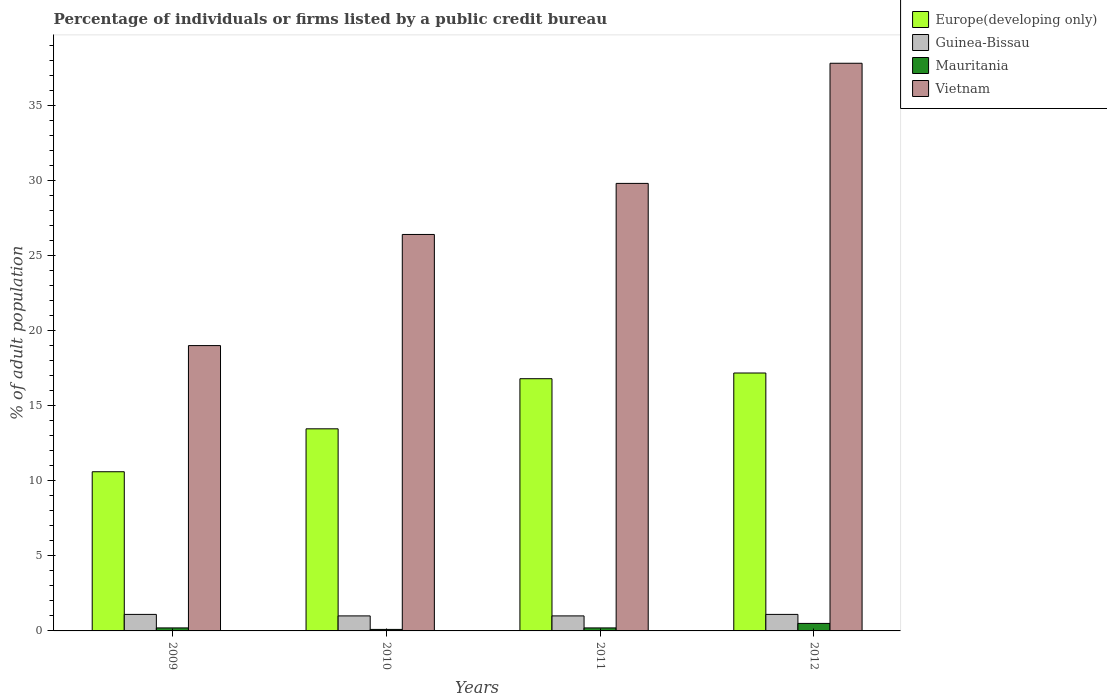How many different coloured bars are there?
Keep it short and to the point. 4. Are the number of bars per tick equal to the number of legend labels?
Provide a short and direct response. Yes. Are the number of bars on each tick of the X-axis equal?
Your answer should be very brief. Yes. How many bars are there on the 2nd tick from the left?
Your answer should be compact. 4. What is the label of the 4th group of bars from the left?
Make the answer very short. 2012. What is the percentage of population listed by a public credit bureau in Europe(developing only) in 2009?
Ensure brevity in your answer.  10.6. Across all years, what is the maximum percentage of population listed by a public credit bureau in Guinea-Bissau?
Your response must be concise. 1.1. Across all years, what is the minimum percentage of population listed by a public credit bureau in Europe(developing only)?
Provide a short and direct response. 10.6. What is the total percentage of population listed by a public credit bureau in Vietnam in the graph?
Offer a terse response. 113. What is the difference between the percentage of population listed by a public credit bureau in Mauritania in 2009 and that in 2010?
Make the answer very short. 0.1. What is the difference between the percentage of population listed by a public credit bureau in Mauritania in 2009 and the percentage of population listed by a public credit bureau in Europe(developing only) in 2012?
Your answer should be very brief. -16.97. In the year 2010, what is the difference between the percentage of population listed by a public credit bureau in Mauritania and percentage of population listed by a public credit bureau in Vietnam?
Make the answer very short. -26.3. What is the ratio of the percentage of population listed by a public credit bureau in Europe(developing only) in 2010 to that in 2012?
Provide a short and direct response. 0.78. What is the difference between the highest and the second highest percentage of population listed by a public credit bureau in Vietnam?
Provide a short and direct response. 8. What is the difference between the highest and the lowest percentage of population listed by a public credit bureau in Mauritania?
Provide a succinct answer. 0.4. What does the 1st bar from the left in 2012 represents?
Keep it short and to the point. Europe(developing only). What does the 2nd bar from the right in 2011 represents?
Provide a short and direct response. Mauritania. Are all the bars in the graph horizontal?
Keep it short and to the point. No. Are the values on the major ticks of Y-axis written in scientific E-notation?
Offer a very short reply. No. How many legend labels are there?
Make the answer very short. 4. What is the title of the graph?
Offer a terse response. Percentage of individuals or firms listed by a public credit bureau. What is the label or title of the Y-axis?
Make the answer very short. % of adult population. What is the % of adult population of Guinea-Bissau in 2009?
Your answer should be compact. 1.1. What is the % of adult population in Mauritania in 2009?
Provide a succinct answer. 0.2. What is the % of adult population of Vietnam in 2009?
Provide a short and direct response. 19. What is the % of adult population in Europe(developing only) in 2010?
Provide a succinct answer. 13.46. What is the % of adult population in Guinea-Bissau in 2010?
Keep it short and to the point. 1. What is the % of adult population in Mauritania in 2010?
Give a very brief answer. 0.1. What is the % of adult population in Vietnam in 2010?
Provide a succinct answer. 26.4. What is the % of adult population in Europe(developing only) in 2011?
Offer a terse response. 16.79. What is the % of adult population of Vietnam in 2011?
Your response must be concise. 29.8. What is the % of adult population of Europe(developing only) in 2012?
Provide a succinct answer. 17.17. What is the % of adult population in Vietnam in 2012?
Make the answer very short. 37.8. Across all years, what is the maximum % of adult population in Europe(developing only)?
Make the answer very short. 17.17. Across all years, what is the maximum % of adult population in Guinea-Bissau?
Provide a succinct answer. 1.1. Across all years, what is the maximum % of adult population of Mauritania?
Provide a succinct answer. 0.5. Across all years, what is the maximum % of adult population of Vietnam?
Provide a short and direct response. 37.8. Across all years, what is the minimum % of adult population of Europe(developing only)?
Give a very brief answer. 10.6. What is the total % of adult population in Europe(developing only) in the graph?
Provide a succinct answer. 58.03. What is the total % of adult population of Vietnam in the graph?
Keep it short and to the point. 113. What is the difference between the % of adult population in Europe(developing only) in 2009 and that in 2010?
Your answer should be compact. -2.86. What is the difference between the % of adult population of Vietnam in 2009 and that in 2010?
Your answer should be compact. -7.4. What is the difference between the % of adult population in Europe(developing only) in 2009 and that in 2011?
Give a very brief answer. -6.19. What is the difference between the % of adult population in Guinea-Bissau in 2009 and that in 2011?
Offer a very short reply. 0.1. What is the difference between the % of adult population in Mauritania in 2009 and that in 2011?
Offer a terse response. 0. What is the difference between the % of adult population of Europe(developing only) in 2009 and that in 2012?
Offer a terse response. -6.57. What is the difference between the % of adult population in Vietnam in 2009 and that in 2012?
Make the answer very short. -18.8. What is the difference between the % of adult population in Europe(developing only) in 2010 and that in 2011?
Make the answer very short. -3.34. What is the difference between the % of adult population in Mauritania in 2010 and that in 2011?
Provide a short and direct response. -0.1. What is the difference between the % of adult population of Europe(developing only) in 2010 and that in 2012?
Provide a short and direct response. -3.72. What is the difference between the % of adult population in Mauritania in 2010 and that in 2012?
Provide a succinct answer. -0.4. What is the difference between the % of adult population in Europe(developing only) in 2011 and that in 2012?
Ensure brevity in your answer.  -0.38. What is the difference between the % of adult population in Guinea-Bissau in 2011 and that in 2012?
Offer a terse response. -0.1. What is the difference between the % of adult population in Europe(developing only) in 2009 and the % of adult population in Mauritania in 2010?
Provide a succinct answer. 10.5. What is the difference between the % of adult population of Europe(developing only) in 2009 and the % of adult population of Vietnam in 2010?
Your answer should be very brief. -15.8. What is the difference between the % of adult population of Guinea-Bissau in 2009 and the % of adult population of Vietnam in 2010?
Your answer should be very brief. -25.3. What is the difference between the % of adult population in Mauritania in 2009 and the % of adult population in Vietnam in 2010?
Keep it short and to the point. -26.2. What is the difference between the % of adult population of Europe(developing only) in 2009 and the % of adult population of Mauritania in 2011?
Your response must be concise. 10.4. What is the difference between the % of adult population in Europe(developing only) in 2009 and the % of adult population in Vietnam in 2011?
Ensure brevity in your answer.  -19.2. What is the difference between the % of adult population in Guinea-Bissau in 2009 and the % of adult population in Mauritania in 2011?
Keep it short and to the point. 0.9. What is the difference between the % of adult population of Guinea-Bissau in 2009 and the % of adult population of Vietnam in 2011?
Your answer should be very brief. -28.7. What is the difference between the % of adult population of Mauritania in 2009 and the % of adult population of Vietnam in 2011?
Make the answer very short. -29.6. What is the difference between the % of adult population of Europe(developing only) in 2009 and the % of adult population of Guinea-Bissau in 2012?
Offer a terse response. 9.5. What is the difference between the % of adult population in Europe(developing only) in 2009 and the % of adult population in Mauritania in 2012?
Offer a very short reply. 10.1. What is the difference between the % of adult population of Europe(developing only) in 2009 and the % of adult population of Vietnam in 2012?
Offer a terse response. -27.2. What is the difference between the % of adult population in Guinea-Bissau in 2009 and the % of adult population in Vietnam in 2012?
Make the answer very short. -36.7. What is the difference between the % of adult population of Mauritania in 2009 and the % of adult population of Vietnam in 2012?
Provide a succinct answer. -37.6. What is the difference between the % of adult population in Europe(developing only) in 2010 and the % of adult population in Guinea-Bissau in 2011?
Offer a terse response. 12.46. What is the difference between the % of adult population of Europe(developing only) in 2010 and the % of adult population of Mauritania in 2011?
Ensure brevity in your answer.  13.26. What is the difference between the % of adult population in Europe(developing only) in 2010 and the % of adult population in Vietnam in 2011?
Make the answer very short. -16.34. What is the difference between the % of adult population in Guinea-Bissau in 2010 and the % of adult population in Mauritania in 2011?
Provide a succinct answer. 0.8. What is the difference between the % of adult population of Guinea-Bissau in 2010 and the % of adult population of Vietnam in 2011?
Your response must be concise. -28.8. What is the difference between the % of adult population of Mauritania in 2010 and the % of adult population of Vietnam in 2011?
Keep it short and to the point. -29.7. What is the difference between the % of adult population in Europe(developing only) in 2010 and the % of adult population in Guinea-Bissau in 2012?
Make the answer very short. 12.36. What is the difference between the % of adult population of Europe(developing only) in 2010 and the % of adult population of Mauritania in 2012?
Your response must be concise. 12.96. What is the difference between the % of adult population of Europe(developing only) in 2010 and the % of adult population of Vietnam in 2012?
Offer a very short reply. -24.34. What is the difference between the % of adult population of Guinea-Bissau in 2010 and the % of adult population of Vietnam in 2012?
Your answer should be very brief. -36.8. What is the difference between the % of adult population in Mauritania in 2010 and the % of adult population in Vietnam in 2012?
Give a very brief answer. -37.7. What is the difference between the % of adult population in Europe(developing only) in 2011 and the % of adult population in Guinea-Bissau in 2012?
Your response must be concise. 15.69. What is the difference between the % of adult population in Europe(developing only) in 2011 and the % of adult population in Mauritania in 2012?
Ensure brevity in your answer.  16.29. What is the difference between the % of adult population of Europe(developing only) in 2011 and the % of adult population of Vietnam in 2012?
Offer a terse response. -21.01. What is the difference between the % of adult population of Guinea-Bissau in 2011 and the % of adult population of Mauritania in 2012?
Offer a terse response. 0.5. What is the difference between the % of adult population of Guinea-Bissau in 2011 and the % of adult population of Vietnam in 2012?
Offer a very short reply. -36.8. What is the difference between the % of adult population of Mauritania in 2011 and the % of adult population of Vietnam in 2012?
Your answer should be compact. -37.6. What is the average % of adult population of Europe(developing only) per year?
Your response must be concise. 14.51. What is the average % of adult population of Vietnam per year?
Ensure brevity in your answer.  28.25. In the year 2009, what is the difference between the % of adult population in Europe(developing only) and % of adult population in Guinea-Bissau?
Your response must be concise. 9.5. In the year 2009, what is the difference between the % of adult population in Europe(developing only) and % of adult population in Mauritania?
Offer a very short reply. 10.4. In the year 2009, what is the difference between the % of adult population in Guinea-Bissau and % of adult population in Mauritania?
Keep it short and to the point. 0.9. In the year 2009, what is the difference between the % of adult population of Guinea-Bissau and % of adult population of Vietnam?
Provide a short and direct response. -17.9. In the year 2009, what is the difference between the % of adult population in Mauritania and % of adult population in Vietnam?
Ensure brevity in your answer.  -18.8. In the year 2010, what is the difference between the % of adult population of Europe(developing only) and % of adult population of Guinea-Bissau?
Make the answer very short. 12.46. In the year 2010, what is the difference between the % of adult population in Europe(developing only) and % of adult population in Mauritania?
Offer a very short reply. 13.36. In the year 2010, what is the difference between the % of adult population of Europe(developing only) and % of adult population of Vietnam?
Keep it short and to the point. -12.94. In the year 2010, what is the difference between the % of adult population in Guinea-Bissau and % of adult population in Mauritania?
Offer a very short reply. 0.9. In the year 2010, what is the difference between the % of adult population of Guinea-Bissau and % of adult population of Vietnam?
Provide a short and direct response. -25.4. In the year 2010, what is the difference between the % of adult population of Mauritania and % of adult population of Vietnam?
Offer a very short reply. -26.3. In the year 2011, what is the difference between the % of adult population of Europe(developing only) and % of adult population of Guinea-Bissau?
Keep it short and to the point. 15.79. In the year 2011, what is the difference between the % of adult population of Europe(developing only) and % of adult population of Mauritania?
Your answer should be compact. 16.59. In the year 2011, what is the difference between the % of adult population of Europe(developing only) and % of adult population of Vietnam?
Keep it short and to the point. -13.01. In the year 2011, what is the difference between the % of adult population in Guinea-Bissau and % of adult population in Mauritania?
Your response must be concise. 0.8. In the year 2011, what is the difference between the % of adult population of Guinea-Bissau and % of adult population of Vietnam?
Your response must be concise. -28.8. In the year 2011, what is the difference between the % of adult population in Mauritania and % of adult population in Vietnam?
Give a very brief answer. -29.6. In the year 2012, what is the difference between the % of adult population in Europe(developing only) and % of adult population in Guinea-Bissau?
Keep it short and to the point. 16.07. In the year 2012, what is the difference between the % of adult population in Europe(developing only) and % of adult population in Mauritania?
Give a very brief answer. 16.67. In the year 2012, what is the difference between the % of adult population in Europe(developing only) and % of adult population in Vietnam?
Your answer should be compact. -20.63. In the year 2012, what is the difference between the % of adult population of Guinea-Bissau and % of adult population of Mauritania?
Your answer should be very brief. 0.6. In the year 2012, what is the difference between the % of adult population of Guinea-Bissau and % of adult population of Vietnam?
Your response must be concise. -36.7. In the year 2012, what is the difference between the % of adult population in Mauritania and % of adult population in Vietnam?
Keep it short and to the point. -37.3. What is the ratio of the % of adult population in Europe(developing only) in 2009 to that in 2010?
Make the answer very short. 0.79. What is the ratio of the % of adult population in Guinea-Bissau in 2009 to that in 2010?
Provide a succinct answer. 1.1. What is the ratio of the % of adult population of Mauritania in 2009 to that in 2010?
Offer a terse response. 2. What is the ratio of the % of adult population of Vietnam in 2009 to that in 2010?
Ensure brevity in your answer.  0.72. What is the ratio of the % of adult population in Europe(developing only) in 2009 to that in 2011?
Your answer should be very brief. 0.63. What is the ratio of the % of adult population of Vietnam in 2009 to that in 2011?
Keep it short and to the point. 0.64. What is the ratio of the % of adult population of Europe(developing only) in 2009 to that in 2012?
Give a very brief answer. 0.62. What is the ratio of the % of adult population of Guinea-Bissau in 2009 to that in 2012?
Ensure brevity in your answer.  1. What is the ratio of the % of adult population of Vietnam in 2009 to that in 2012?
Your answer should be compact. 0.5. What is the ratio of the % of adult population of Europe(developing only) in 2010 to that in 2011?
Your response must be concise. 0.8. What is the ratio of the % of adult population of Guinea-Bissau in 2010 to that in 2011?
Provide a short and direct response. 1. What is the ratio of the % of adult population in Mauritania in 2010 to that in 2011?
Provide a succinct answer. 0.5. What is the ratio of the % of adult population in Vietnam in 2010 to that in 2011?
Your response must be concise. 0.89. What is the ratio of the % of adult population in Europe(developing only) in 2010 to that in 2012?
Make the answer very short. 0.78. What is the ratio of the % of adult population in Guinea-Bissau in 2010 to that in 2012?
Offer a very short reply. 0.91. What is the ratio of the % of adult population in Vietnam in 2010 to that in 2012?
Give a very brief answer. 0.7. What is the ratio of the % of adult population of Europe(developing only) in 2011 to that in 2012?
Keep it short and to the point. 0.98. What is the ratio of the % of adult population of Vietnam in 2011 to that in 2012?
Make the answer very short. 0.79. What is the difference between the highest and the second highest % of adult population of Europe(developing only)?
Provide a short and direct response. 0.38. What is the difference between the highest and the second highest % of adult population in Vietnam?
Keep it short and to the point. 8. What is the difference between the highest and the lowest % of adult population in Europe(developing only)?
Keep it short and to the point. 6.57. What is the difference between the highest and the lowest % of adult population of Guinea-Bissau?
Your answer should be compact. 0.1. 